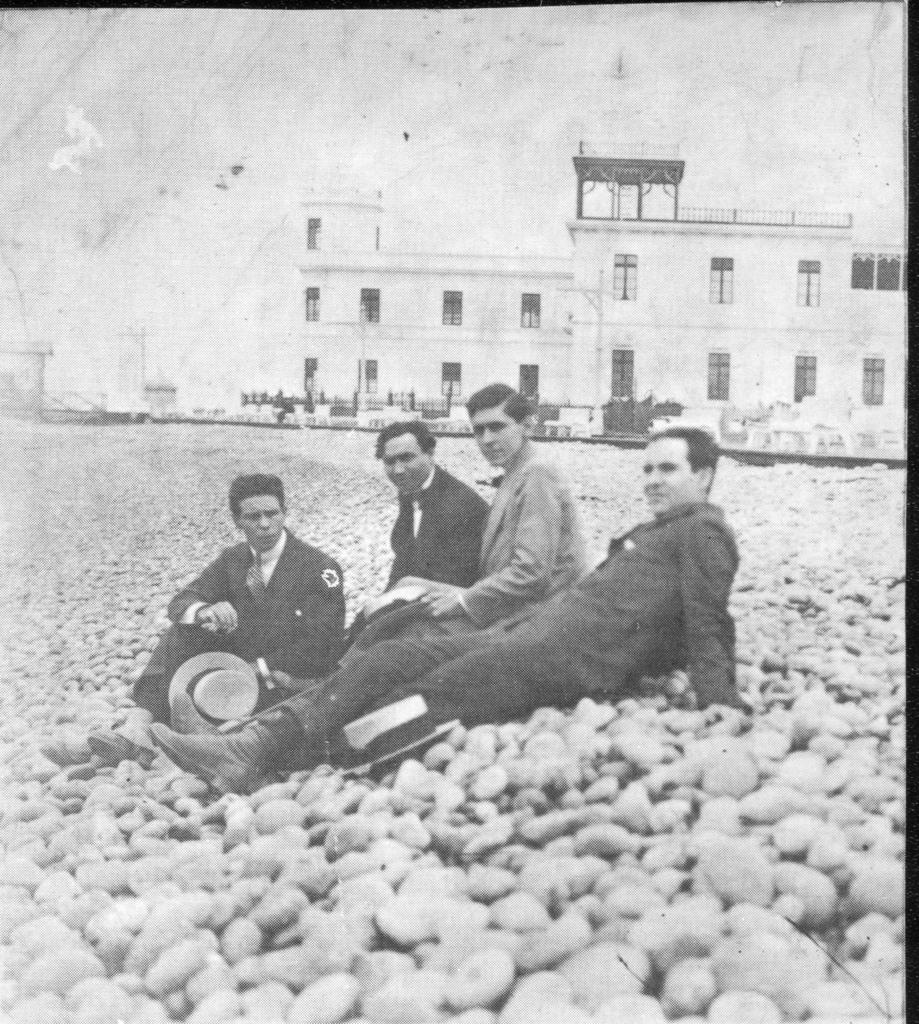What is the color scheme of the image? The image is black and white. What are the four men in the foreground doing? The four men are sitting on stones in the foreground. What can be seen in the background of the image? There are buildings, trees, and a road in the background. What is the condition of the sky in the image? The sky is cloudy in the image. What type of coach can be seen in the image? There is no coach present in the image. Is there a crib visible in the image? There is no crib present in the image. 